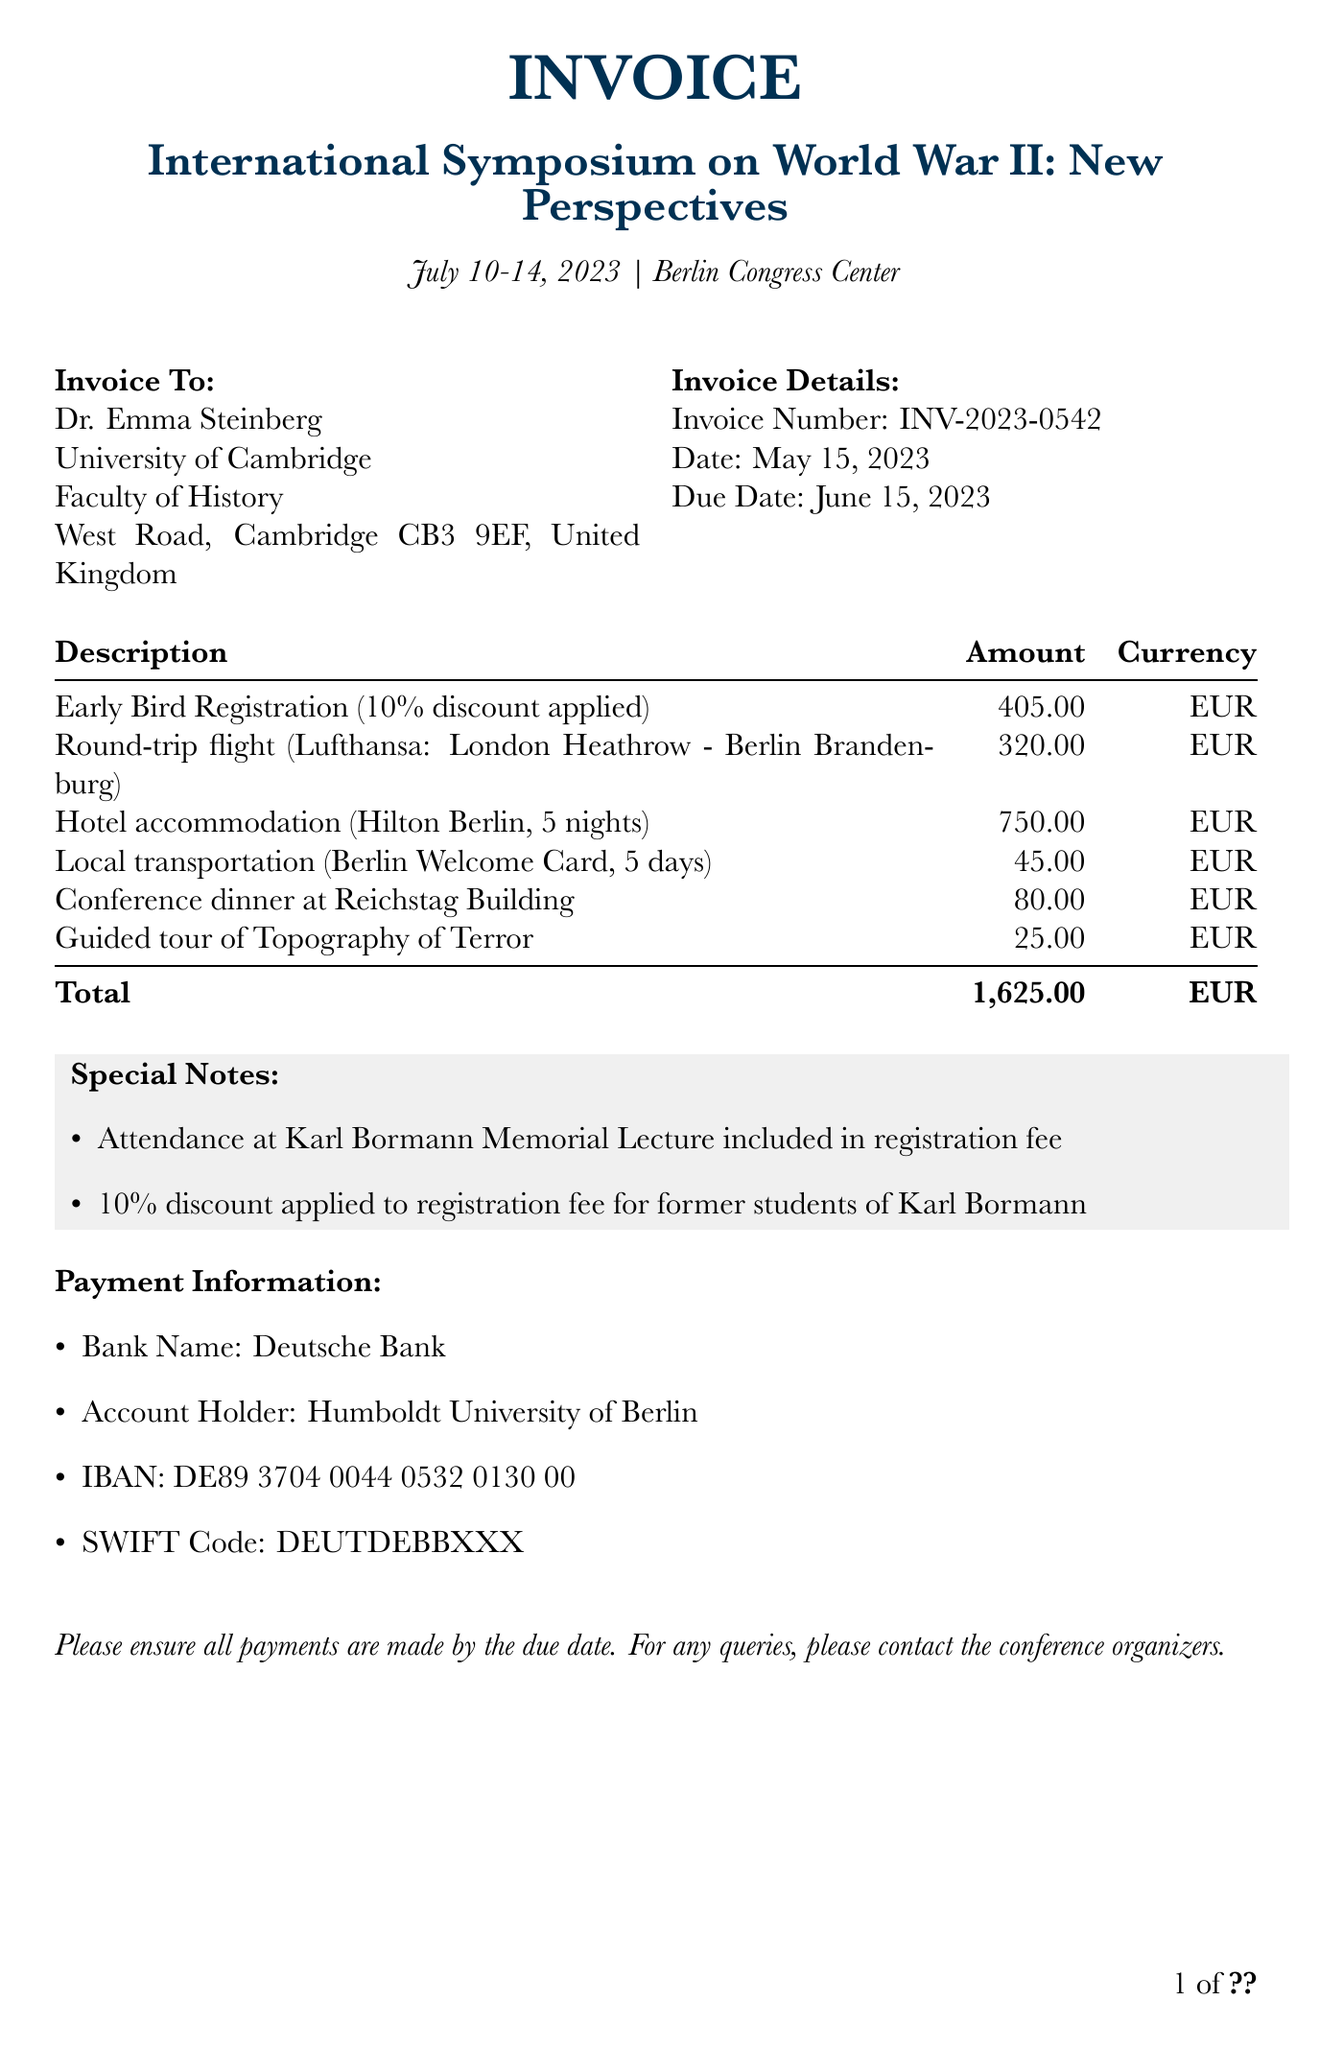What is the invoice number? The invoice number is presented in the document to uniquely identify this transaction.
Answer: INV-2023-0542 Who is the client? The document lists Dr. Emma Steinberg as the client who is being invoiced.
Answer: Dr. Emma Steinberg What is the registration fee amount? The amount for the Early Bird Registration is detailed in the invoice.
Answer: 450 What are the travel expenses for the round-trip flight? The specific cost for the round-trip flight is included in the document.
Answer: 320 What is the total amount due? The total amount is calculated by summing all expenses listed in the document.
Answer: 1625 What institution is Dr. Emma Steinberg affiliated with? The document specifies the institution associated with the client for billing purposes.
Answer: University of Cambridge When is the invoice due date? The due date is clearly stated in the document, indicating when payment should be made.
Answer: June 15, 2023 What event did Dr. Emma Steinberg register for? The conference name is mentioned in the document as the event for which she registered.
Answer: International Symposium on World War II: New Perspectives What special discount is noted in the document? The document lists the discount applicable to the registration fee based on a specific criterion.
Answer: 10% discount 